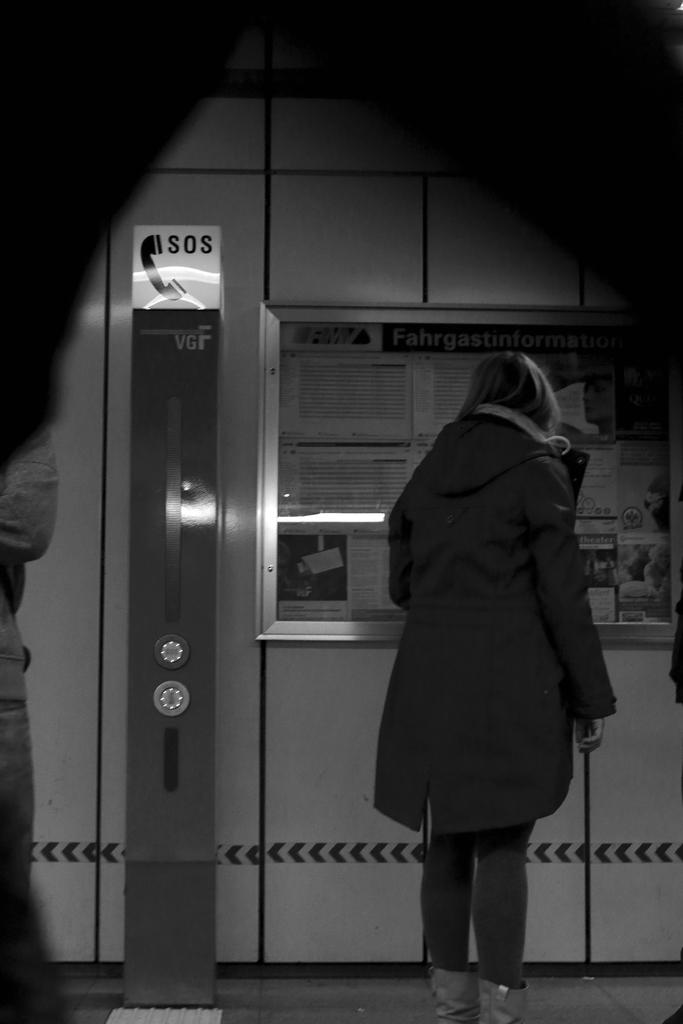What does it say on the phone sign?
Offer a very short reply. Sos. 